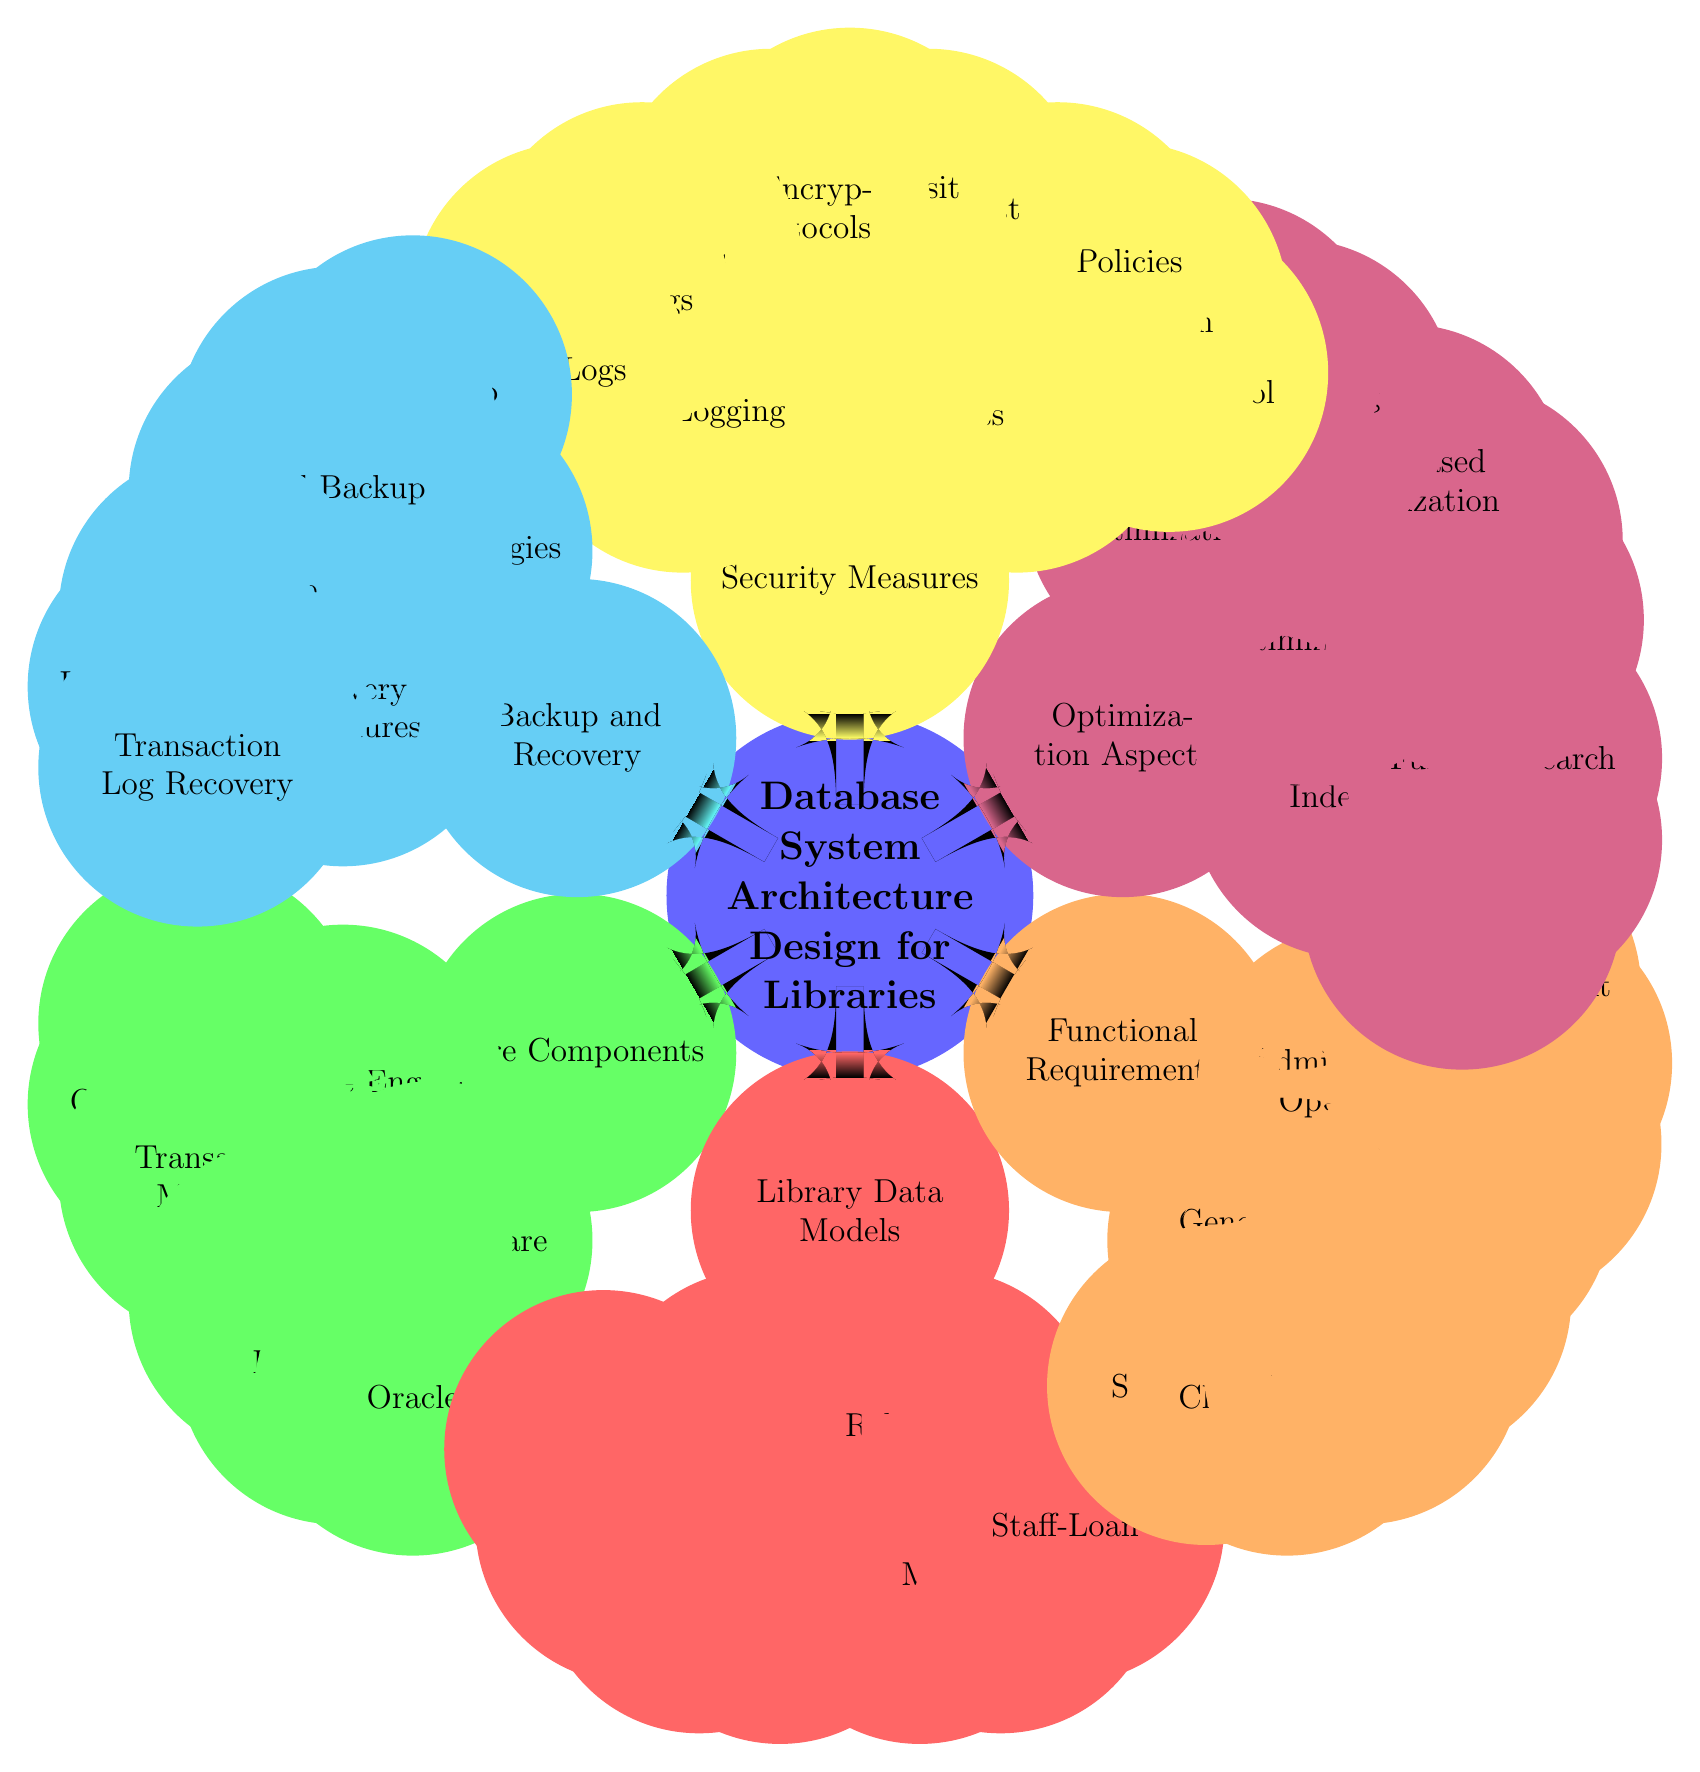What are the core components of the database system architecture for libraries? The core components are divided into two primary categories: Database Engine and DBMS Software. The Database Engine includes the Storage Manager, Query Processor, and Transaction Manager. The DBMS Software includes MySQL, PostgreSQL, and Oracle.
Answer: Core Components: Database Engine, DBMS Software How many entities are listed in the Library Data Models? The Library Data Models includes five entities: Books, Members, Staff, Loans, and Fines. By counting these nodes, we find there are a total of five.
Answer: 5 What type of backup strategies are mentioned in the Backup and Recovery section? The Backup Strategies include Full Backup, Incremental Backup, and Differential Backup. These are explicitly listed under the Backup Strategies node.
Answer: Full Backup, Incremental Backup, Differential Backup Which security measure focuses on managing user permissions? Access Control is the security measure that focuses specifically on managing user permissions, which includes Role-Based Access Control, User Authentication, and Password Policies.
Answer: Access Control What relationship exists between Members and Loans? The diagram indicates a relationship termed "Member-Loan," which connects the entities Members and Loans. This is found in the Relationships section of the Library Data Models.
Answer: Member-Loan What optimization technique involves analyzing how queries will execute? Query Execution Plans is the optimization technique that analyzes how queries will execute, providing insight into performance improvements. It is found in the Query Optimization section of Optimization Aspects.
Answer: Query Execution Plans What is included under Data Encryption for security measures? Data Encryption includes three measures: Data-at-Rest, Data-in-Transit, and Strict Encryption Protocols, as shown in the Security Measures section of the diagram.
Answer: Data-at-Rest, Data-in-Transit, Strict Encryption Protocols Which DBMS software is associated with the Core Components of the architecture? The DBMS Software section lists three types: MySQL, PostgreSQL, and Oracle, indicating the database management software options associated with the architecture.
Answer: MySQL, PostgreSQL, Oracle What type of management falls under Administrative Operations? Administrative Operations encompasses tasks like Cataloging, User Management, Inventory Management, and Staff Management, focusing on administrative duties related to library data.
Answer: Cataloging, User Management, Inventory Management, Staff Management 